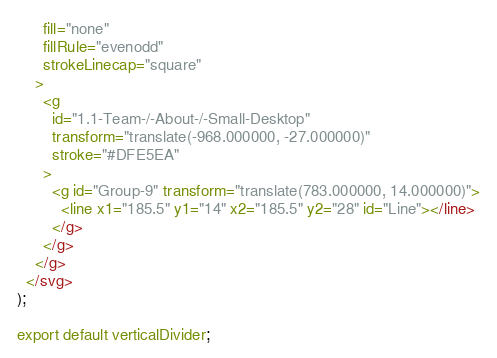<code> <loc_0><loc_0><loc_500><loc_500><_TypeScript_>      fill="none"
      fillRule="evenodd"
      strokeLinecap="square"
    >
      <g
        id="1.1-Team-/-About-/-Small-Desktop"
        transform="translate(-968.000000, -27.000000)"
        stroke="#DFE5EA"
      >
        <g id="Group-9" transform="translate(783.000000, 14.000000)">
          <line x1="185.5" y1="14" x2="185.5" y2="28" id="Line"></line>
        </g>
      </g>
    </g>
  </svg>
);

export default verticalDivider;
</code> 